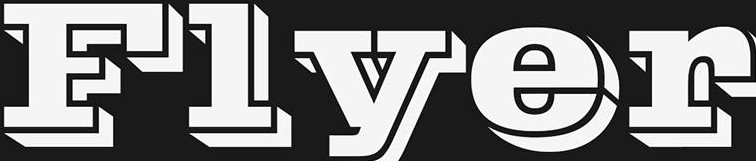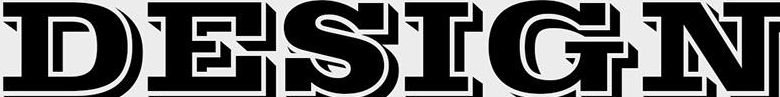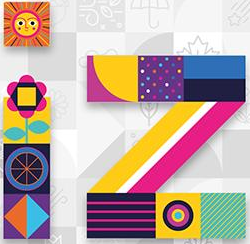What text is displayed in these images sequentially, separated by a semicolon? Flyer; DESIGN; iz 